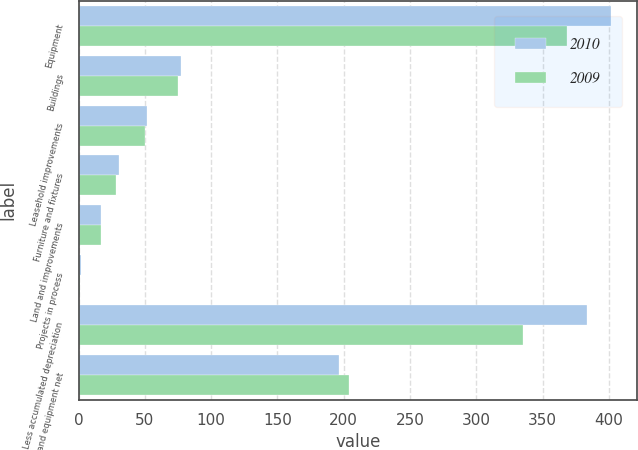Convert chart to OTSL. <chart><loc_0><loc_0><loc_500><loc_500><stacked_bar_chart><ecel><fcel>Equipment<fcel>Buildings<fcel>Leasehold improvements<fcel>Furniture and fixtures<fcel>Land and improvements<fcel>Projects in process<fcel>Less accumulated depreciation<fcel>Property and equipment net<nl><fcel>2010<fcel>401.5<fcel>77.5<fcel>51.9<fcel>30.3<fcel>16.9<fcel>2<fcel>383.6<fcel>196.5<nl><fcel>2009<fcel>368.5<fcel>75.2<fcel>50<fcel>28.1<fcel>16.9<fcel>1<fcel>335.4<fcel>204.3<nl></chart> 